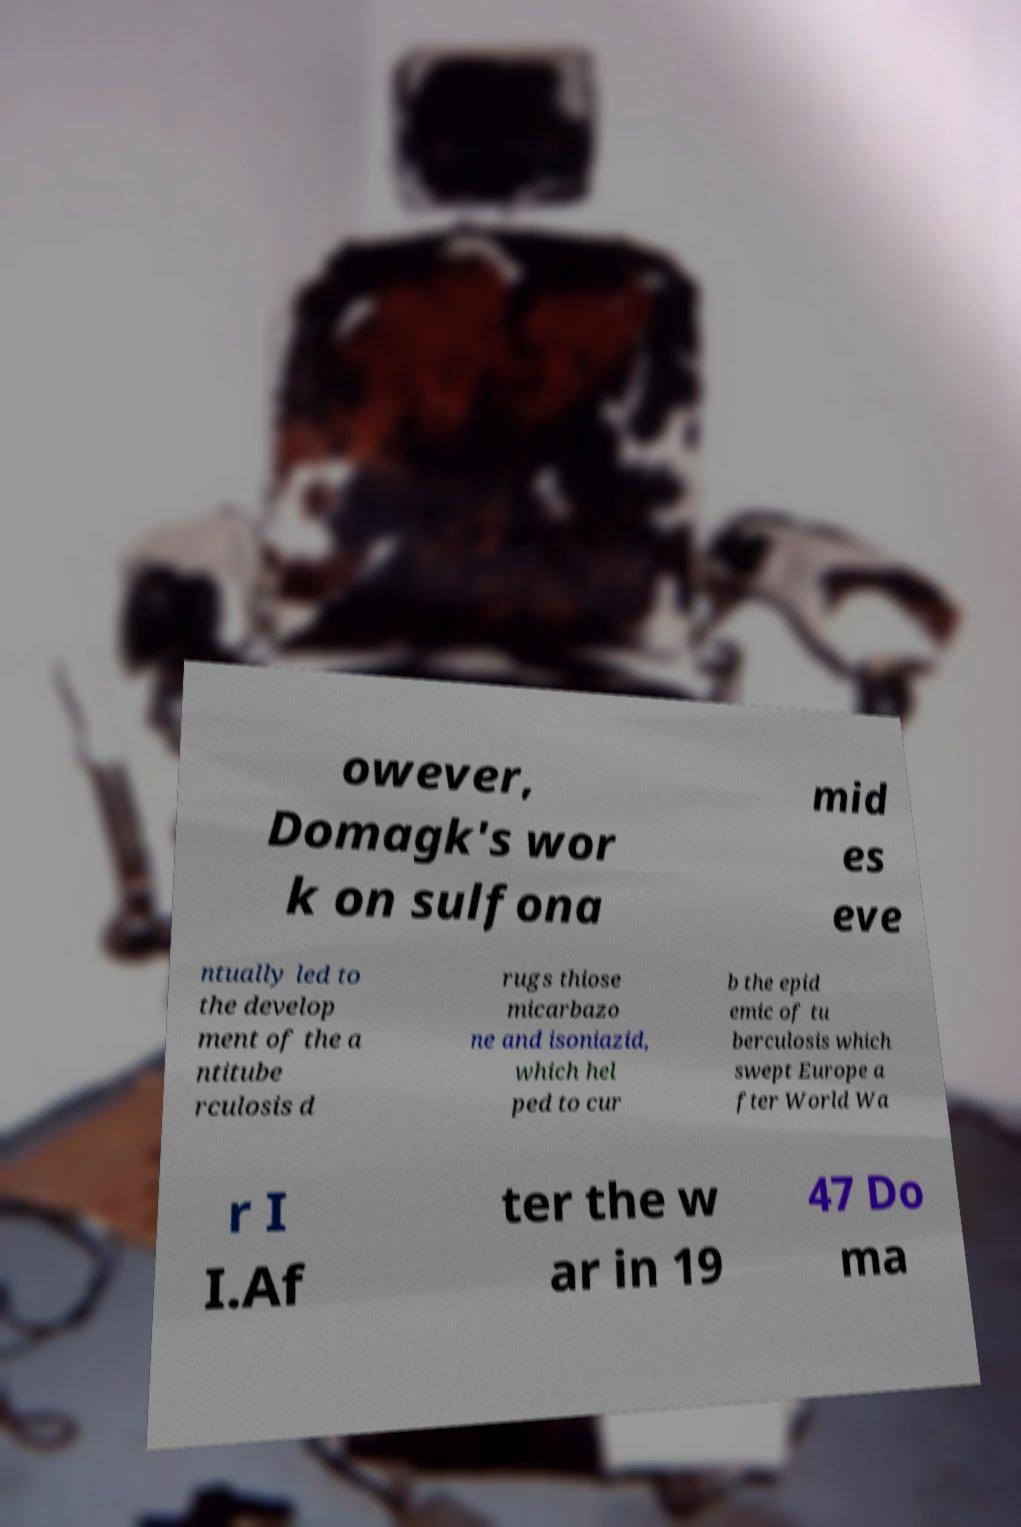I need the written content from this picture converted into text. Can you do that? owever, Domagk's wor k on sulfona mid es eve ntually led to the develop ment of the a ntitube rculosis d rugs thiose micarbazo ne and isoniazid, which hel ped to cur b the epid emic of tu berculosis which swept Europe a fter World Wa r I I.Af ter the w ar in 19 47 Do ma 